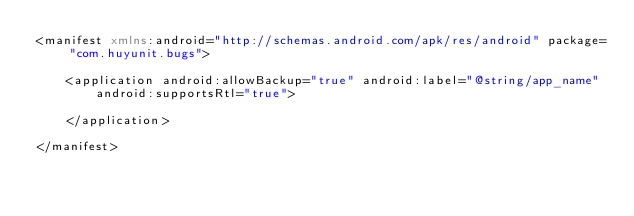<code> <loc_0><loc_0><loc_500><loc_500><_XML_><manifest xmlns:android="http://schemas.android.com/apk/res/android" package="com.huyunit.bugs">

    <application android:allowBackup="true" android:label="@string/app_name"
        android:supportsRtl="true">

    </application>

</manifest>
</code> 